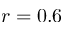<formula> <loc_0><loc_0><loc_500><loc_500>r = 0 . 6</formula> 